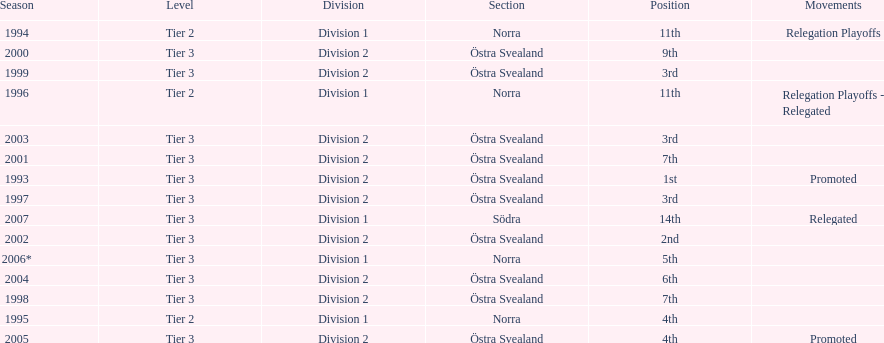Help me parse the entirety of this table. {'header': ['Season', 'Level', 'Division', 'Section', 'Position', 'Movements'], 'rows': [['1994', 'Tier 2', 'Division 1', 'Norra', '11th', 'Relegation Playoffs'], ['2000', 'Tier 3', 'Division 2', 'Östra Svealand', '9th', ''], ['1999', 'Tier 3', 'Division 2', 'Östra Svealand', '3rd', ''], ['1996', 'Tier 2', 'Division 1', 'Norra', '11th', 'Relegation Playoffs - Relegated'], ['2003', 'Tier 3', 'Division 2', 'Östra Svealand', '3rd', ''], ['2001', 'Tier 3', 'Division 2', 'Östra Svealand', '7th', ''], ['1993', 'Tier 3', 'Division 2', 'Östra Svealand', '1st', 'Promoted'], ['1997', 'Tier 3', 'Division 2', 'Östra Svealand', '3rd', ''], ['2007', 'Tier 3', 'Division 1', 'Södra', '14th', 'Relegated'], ['2002', 'Tier 3', 'Division 2', 'Östra Svealand', '2nd', ''], ['2006*', 'Tier 3', 'Division 1', 'Norra', '5th', ''], ['2004', 'Tier 3', 'Division 2', 'Östra Svealand', '6th', ''], ['1998', 'Tier 3', 'Division 2', 'Östra Svealand', '7th', ''], ['1995', 'Tier 2', 'Division 1', 'Norra', '4th', ''], ['2005', 'Tier 3', 'Division 2', 'Östra Svealand', '4th', 'Promoted']]} How many times is division 2 listed as the division? 10. 